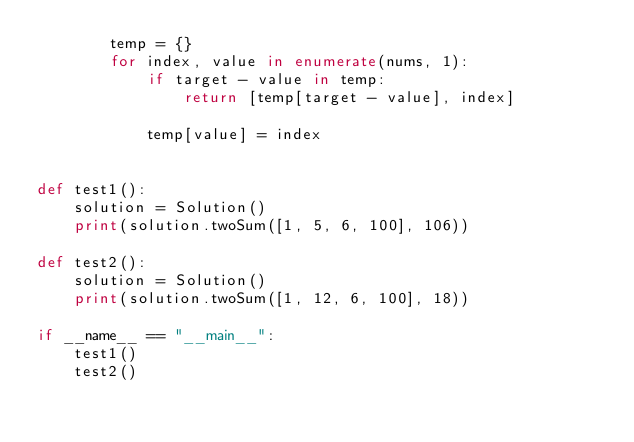<code> <loc_0><loc_0><loc_500><loc_500><_Python_>        temp = {}
        for index, value in enumerate(nums, 1):
            if target - value in temp:
                return [temp[target - value], index]

            temp[value] = index


def test1():
    solution = Solution()
    print(solution.twoSum([1, 5, 6, 100], 106))

def test2():
    solution = Solution()
    print(solution.twoSum([1, 12, 6, 100], 18))

if __name__ == "__main__":
    test1()
    test2()</code> 